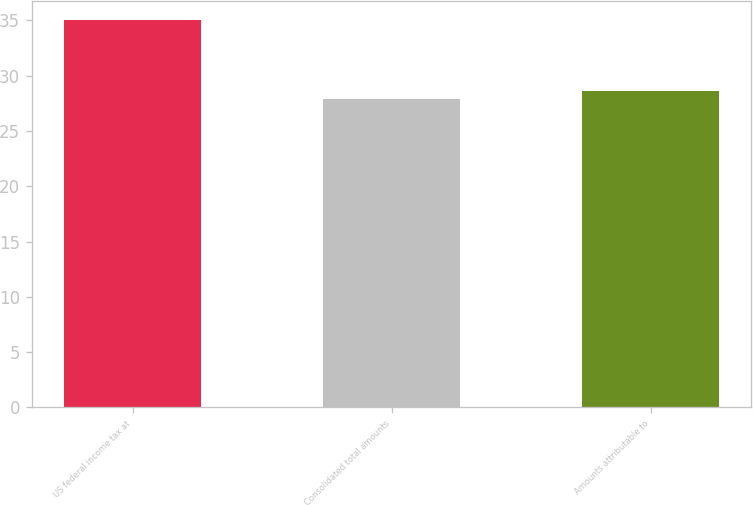Convert chart to OTSL. <chart><loc_0><loc_0><loc_500><loc_500><bar_chart><fcel>US federal income tax at<fcel>Consolidated total amounts<fcel>Amounts attributable to<nl><fcel>35<fcel>27.9<fcel>28.61<nl></chart> 